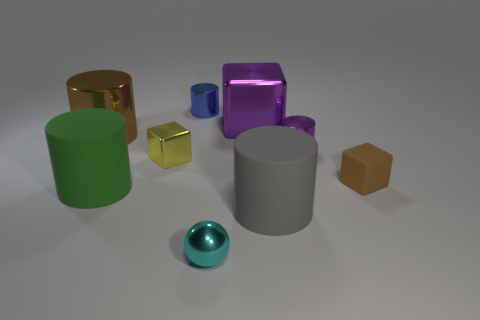Subtract all brown cylinders. How many cylinders are left? 4 Subtract all green cylinders. How many cylinders are left? 4 Subtract all blue cylinders. Subtract all purple balls. How many cylinders are left? 4 Add 1 brown shiny things. How many objects exist? 10 Subtract all cubes. How many objects are left? 6 Add 1 tiny red rubber cubes. How many tiny red rubber cubes exist? 1 Subtract 1 yellow cubes. How many objects are left? 8 Subtract all yellow things. Subtract all big purple metal blocks. How many objects are left? 7 Add 8 green rubber cylinders. How many green rubber cylinders are left? 9 